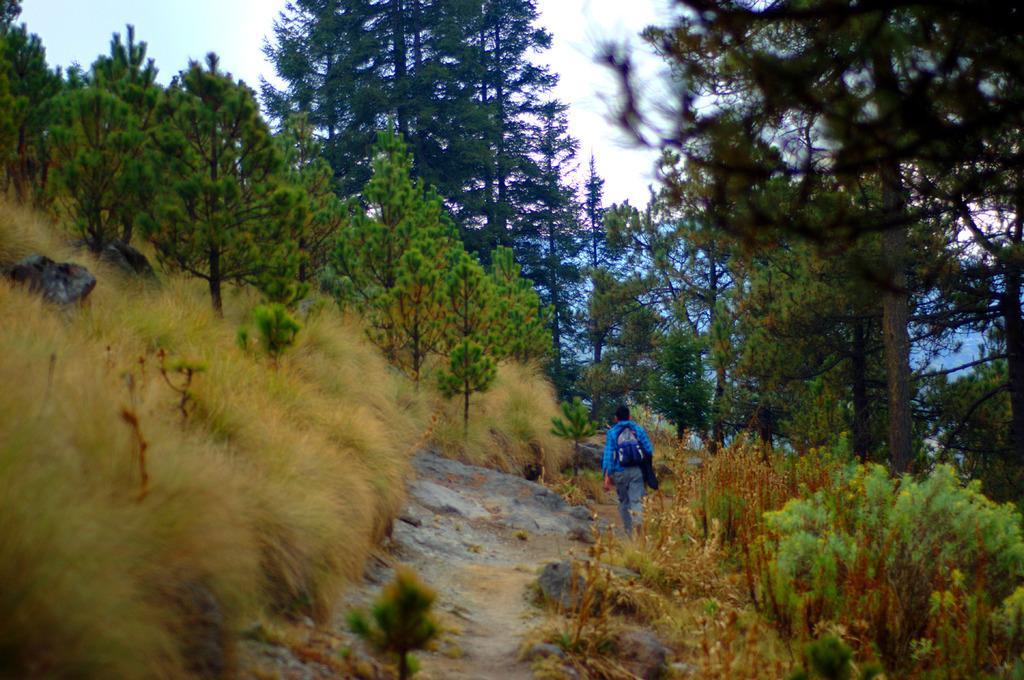Please provide a concise description of this image. In this image I can see in the middle a person is walking, there are trees on either side of this image. At the top there is the sky. 